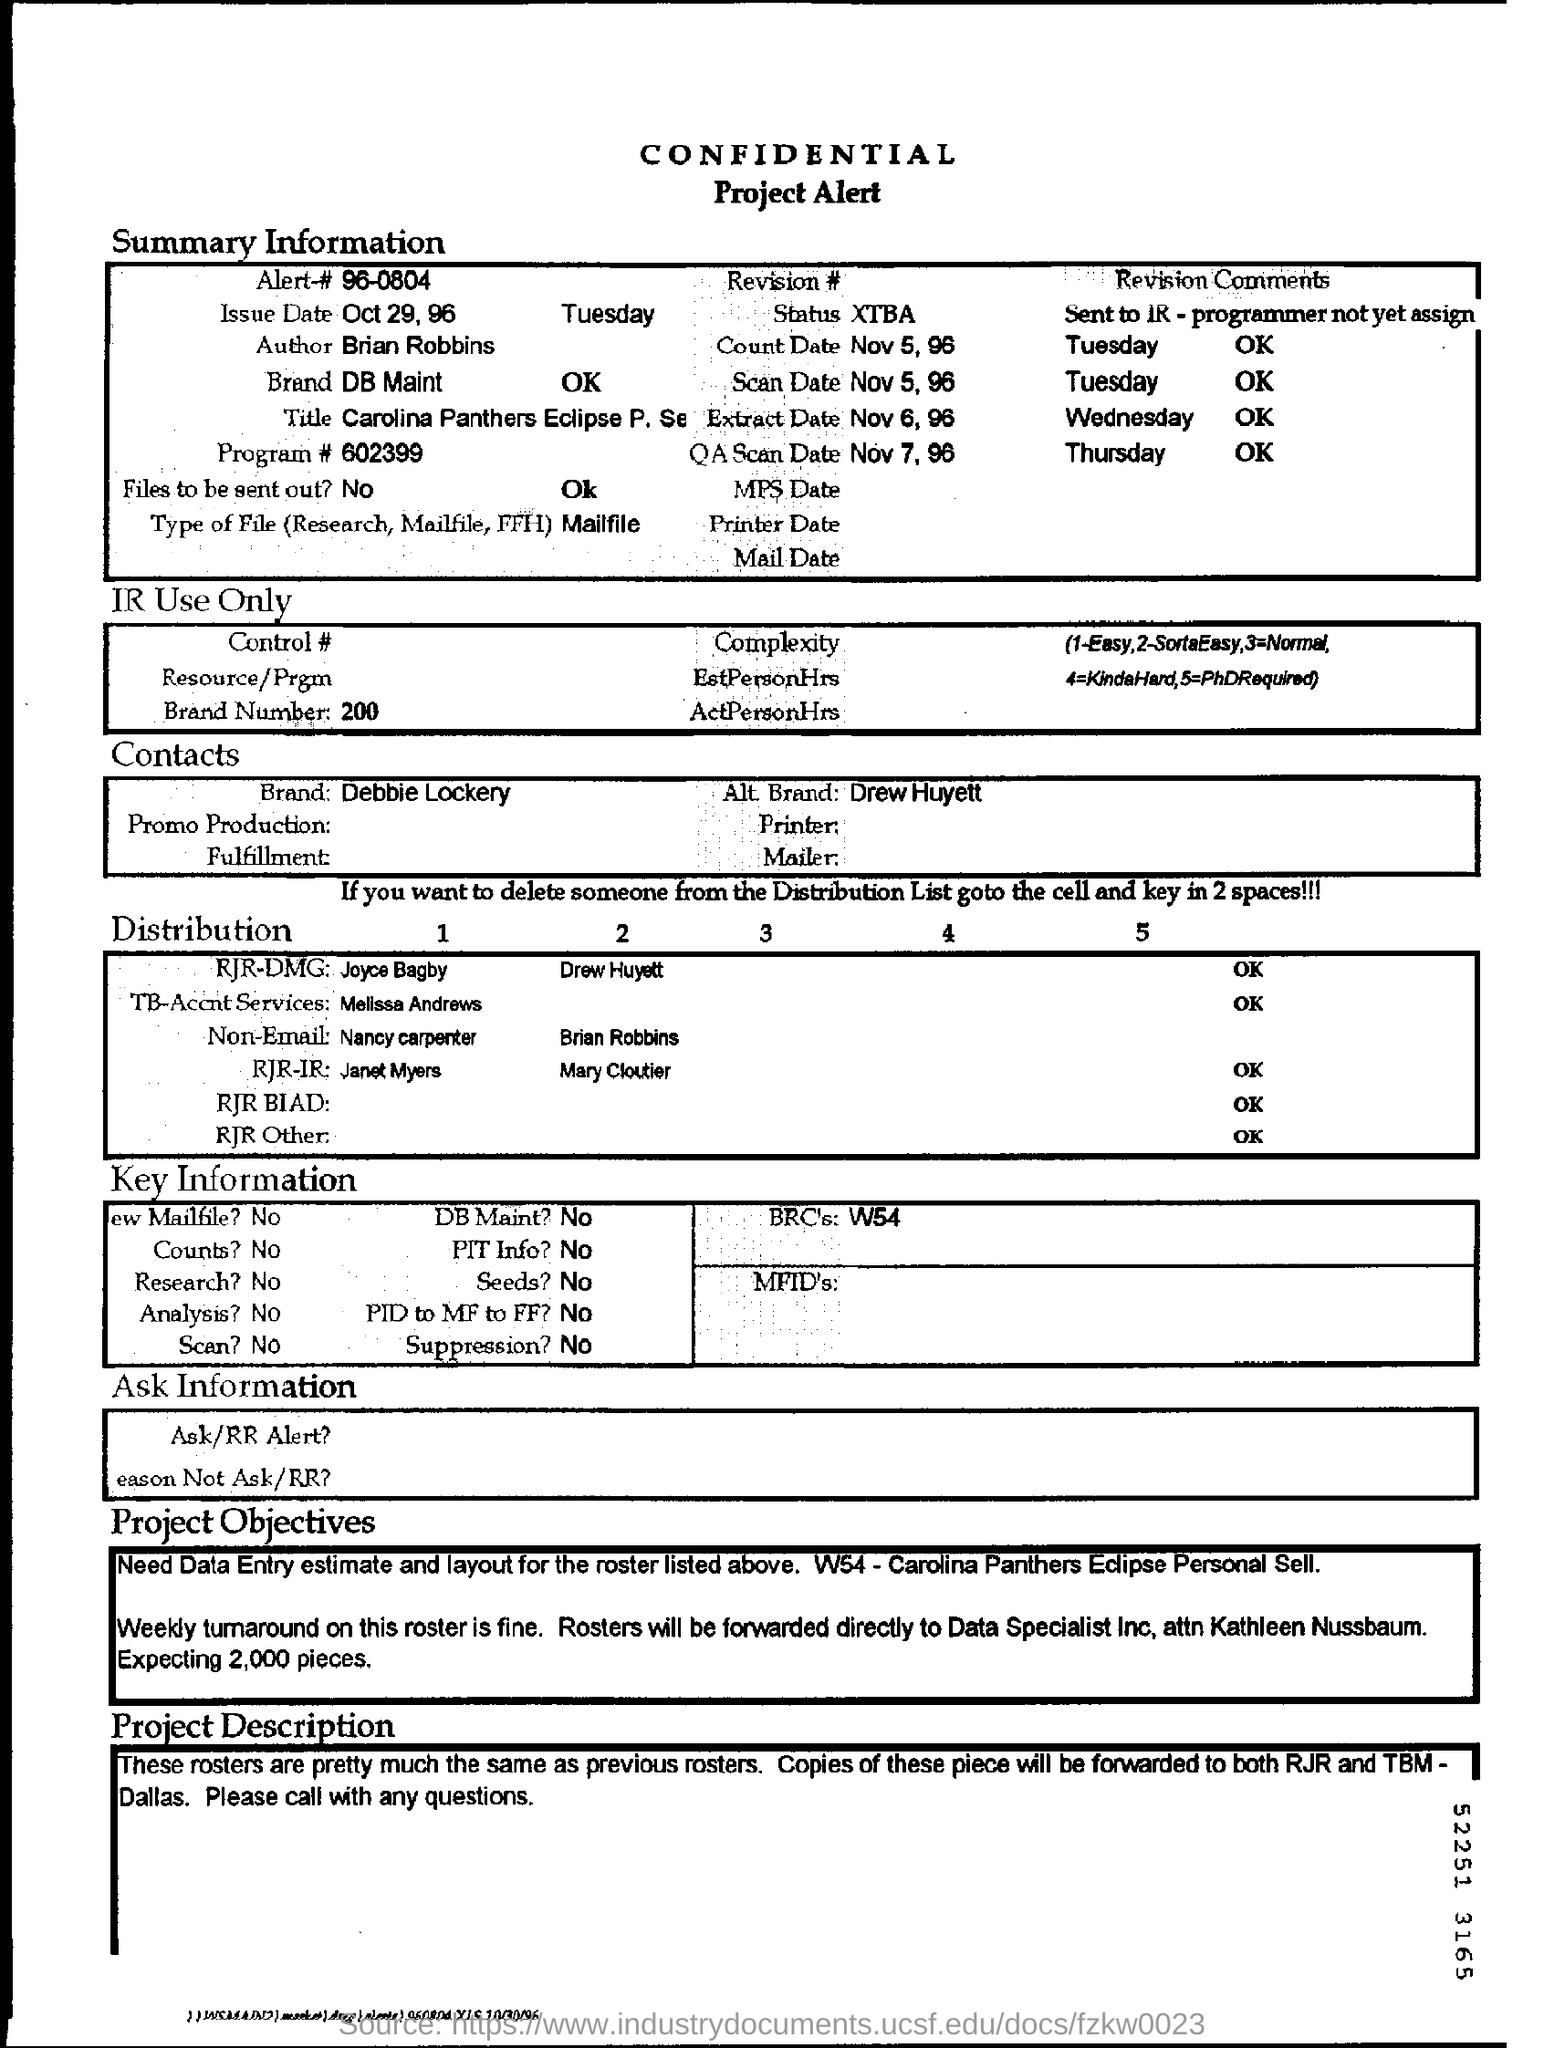What is the heading of the document?
Provide a succinct answer. CONFIDENTIAL. Who is the Author of this document?
Ensure brevity in your answer.  Brian Robbins. What is the Brand mentioned in Summary Information?
Give a very brief answer. DB Maint. Are the Files meant be sent out?
Give a very brief answer. No. 